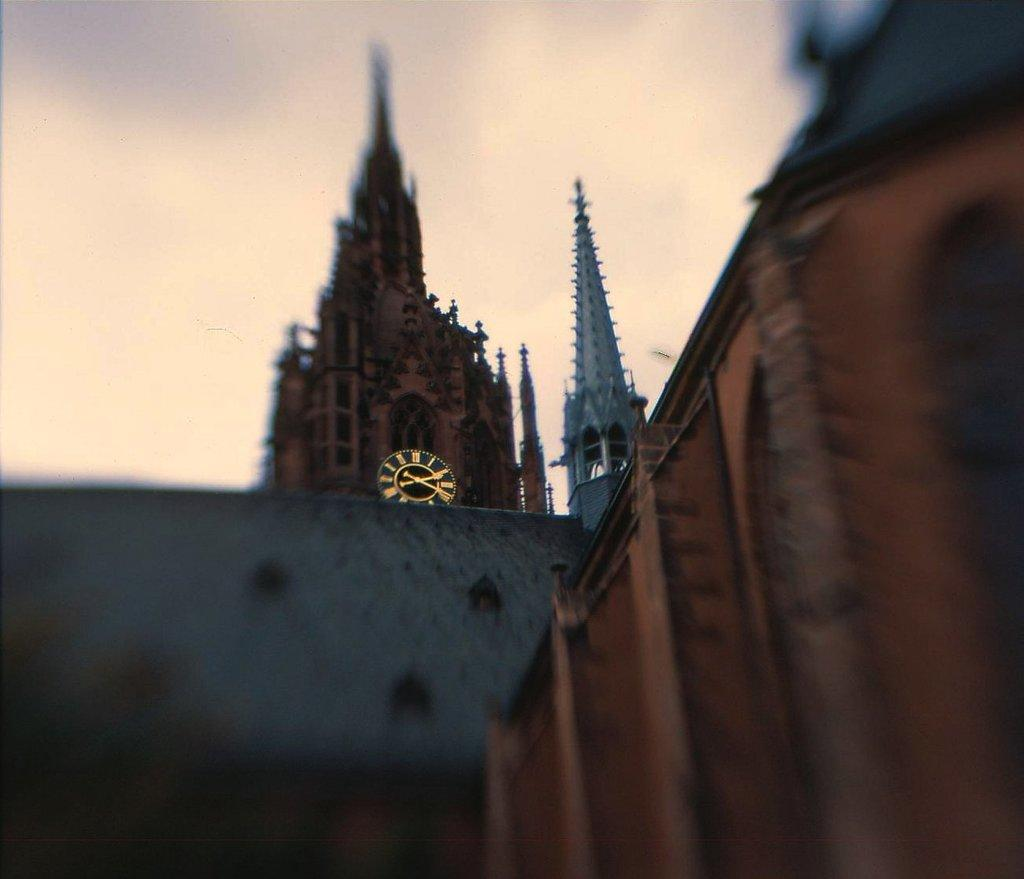What type of structures are visible on the ground in the image? There are buildings on the ground in the image. What can be seen in the sky in the background of the image? There are clouds in the sky in the background of the image. What type of test is being conducted on the buildings in the image? There is no indication of a test being conducted in the image; it simply shows buildings on the ground and clouds in the sky. 